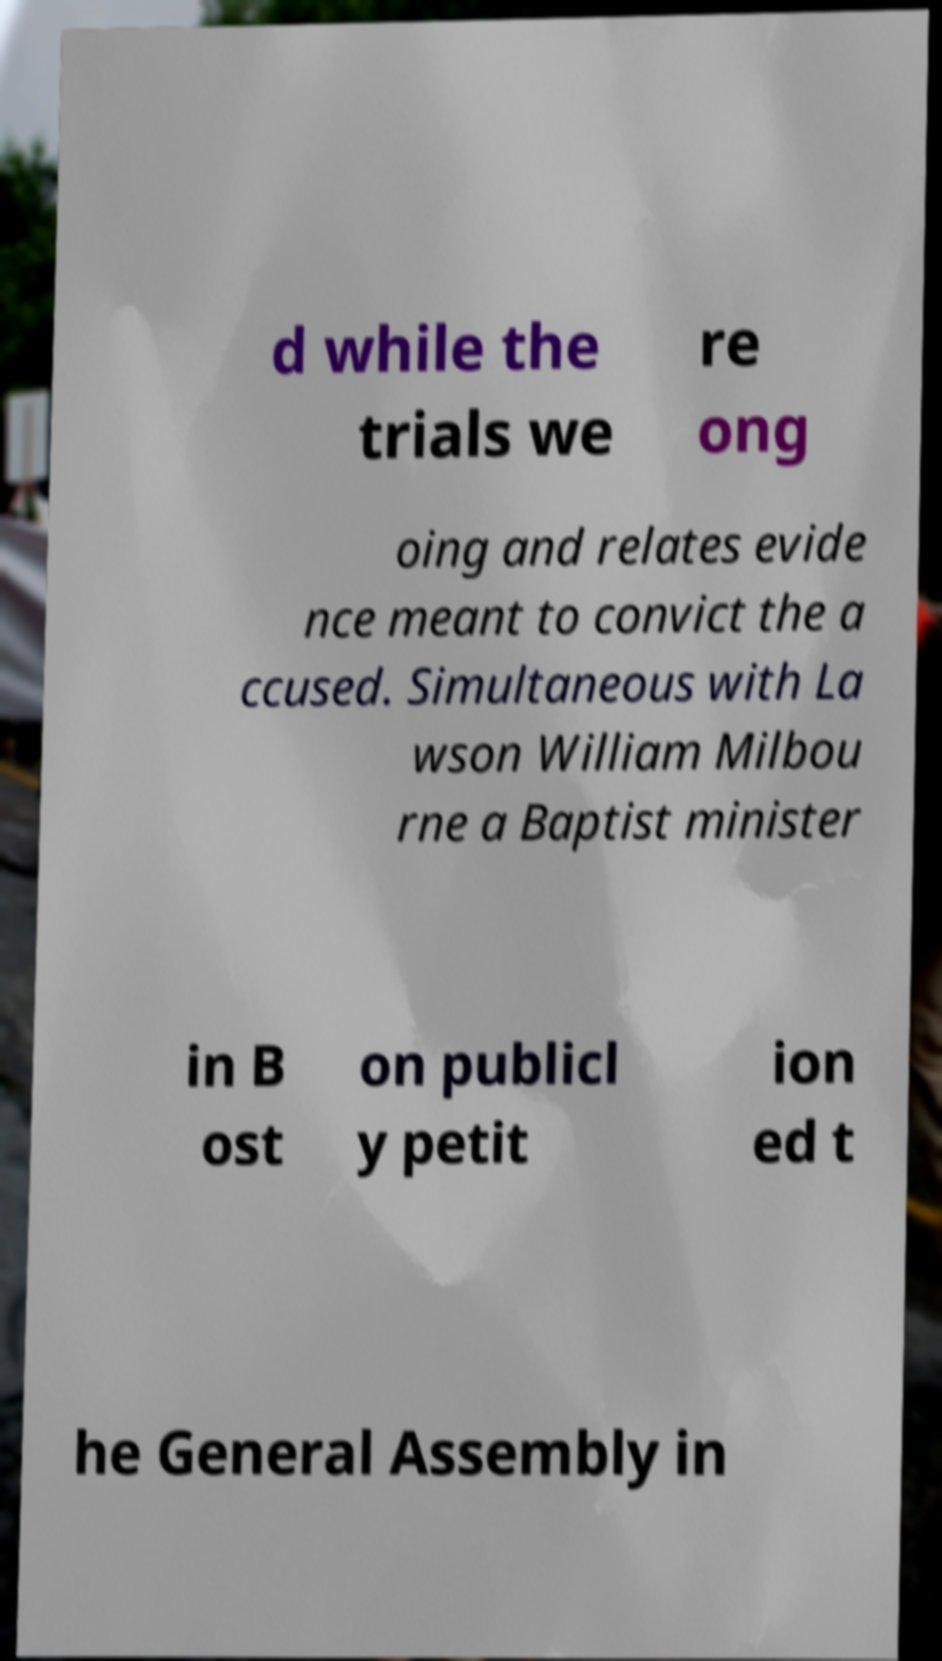Please identify and transcribe the text found in this image. d while the trials we re ong oing and relates evide nce meant to convict the a ccused. Simultaneous with La wson William Milbou rne a Baptist minister in B ost on publicl y petit ion ed t he General Assembly in 